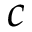Convert formula to latex. <formula><loc_0><loc_0><loc_500><loc_500>c</formula> 